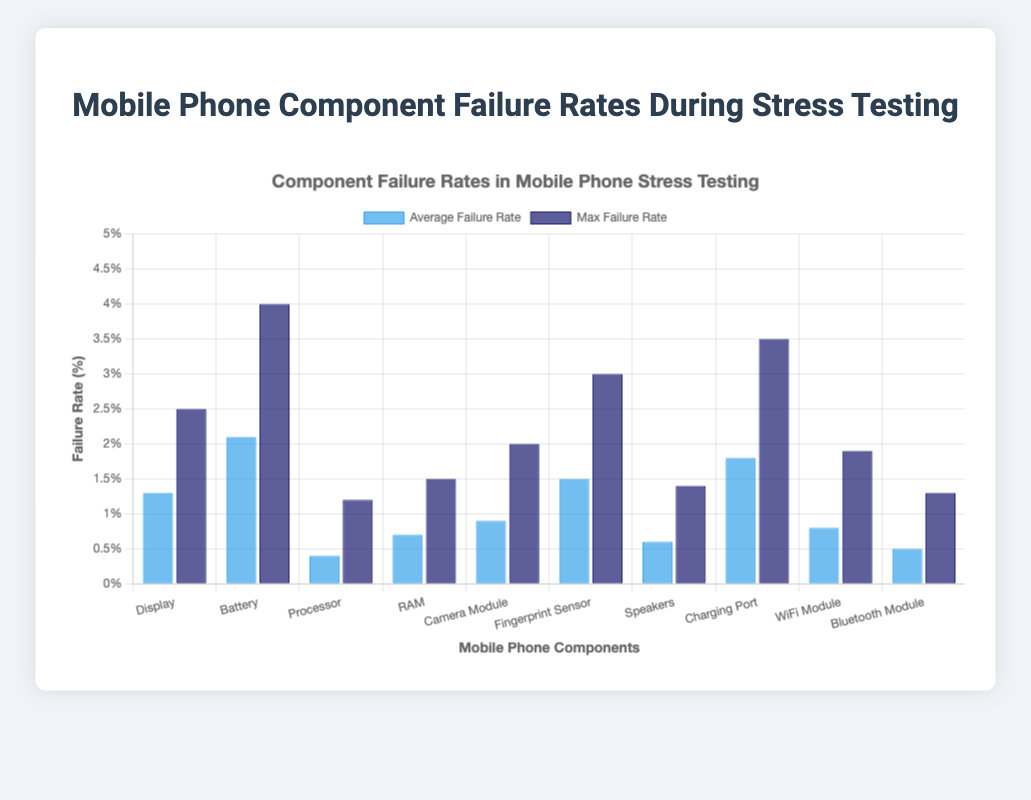What is the component with the highest average failure rate? Looking at the bar chart, the highest blue bar represents the component with the highest average failure rate. It's the "Battery" bar, which visually appears higher than the others.
Answer: Battery Which component has the smallest difference between its average failure rate and max failure rate? Subtract the height of the blue bar (average failure rate) from the height of the dark blue bar (max failure rate) for each component. The "Bluetooth Module" has the smallest difference, calculated as 1.3 - 0.5 = 0.8.
Answer: Bluetooth Module Which two components have the highest max failure rates? Check the dark blue bars and identify the two highest. The "Battery" component has the highest max failure rate at 4.0%, followed by the "Charging Port" at 3.5%.
Answer: Battery and Charging Port How much higher is the max failure rate of the Fingerprint Sensor compared to its average failure rate? Subtract the average failure rate from the max failure rate for the Fingerprint Sensor: 3.0 - 1.5 = 1.5%.
Answer: 1.5% Which component shows the largest spread between its average and maximum failure rates? Identify the component with the largest vertical distance between its blue and dark blue bars. The "Battery" has the largest spread with a difference calculated as 4.0 - 2.1 = 1.9%.
Answer: Battery What is the total combined average failure rate of the Processor, RAM, and WiFi Module? Add the average failure rates of the three components: Processor (0.4%) + RAM (0.7%) + WiFi Module (0.8%) = 1.9%.
Answer: 1.9% What is the average of the maximum failure rates for Display, Processor, RAM, and Camera Module? Add the max failure rates and divide by the number of components: (2.5 + 1.2 + 1.5 + 2.0) / 4 = 1.8%.
Answer: 1.8% From the visual appearance of the bars, which component has a lower average failure rate than the Charging Port but a higher max failure rate? The blue bar of the Charging Port is 1.8%, so look for components with a blue bar lower and a dark blue bar higher. The "Fingerprint Sensor" fits both criteria with an average failure rate of 1.5% and a max of 3.0%.
Answer: Fingerprint Sensor 